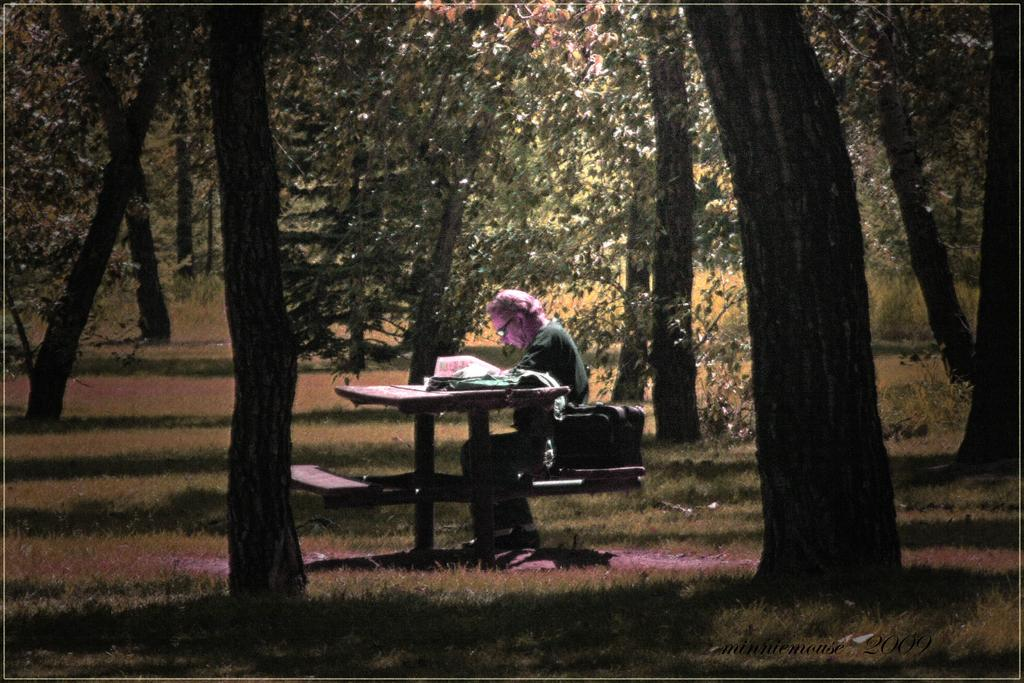What is the man in the image doing? The man is sitting on a bench in the image. What is the man looking at while sitting on the bench? The man is looking at a newspaper. What can be seen in the background of the image? There are trees and grass in the background of the image. How many branches can be seen on the man in the image? There are no branches visible on the man in the image. What type of transport is the man using to sit on the bench? The man is not using any transport to sit on the bench; he is simply sitting on it. 